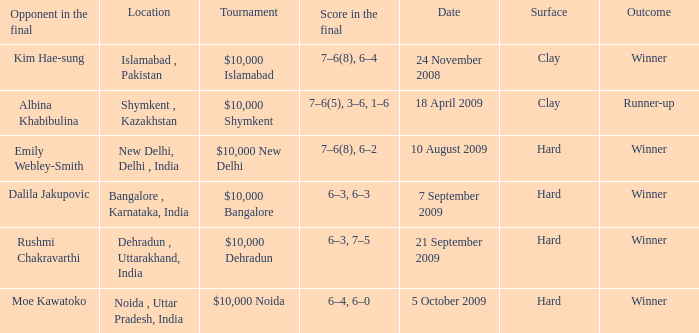What is the name of the tournament where outcome is runner-up $10,000 Shymkent. I'm looking to parse the entire table for insights. Could you assist me with that? {'header': ['Opponent in the final', 'Location', 'Tournament', 'Score in the final', 'Date', 'Surface', 'Outcome'], 'rows': [['Kim Hae-sung', 'Islamabad , Pakistan', '$10,000 Islamabad', '7–6(8), 6–4', '24 November 2008', 'Clay', 'Winner'], ['Albina Khabibulina', 'Shymkent , Kazakhstan', '$10,000 Shymkent', '7–6(5), 3–6, 1–6', '18 April 2009', 'Clay', 'Runner-up'], ['Emily Webley-Smith', 'New Delhi, Delhi , India', '$10,000 New Delhi', '7–6(8), 6–2', '10 August 2009', 'Hard', 'Winner'], ['Dalila Jakupovic', 'Bangalore , Karnataka, India', '$10,000 Bangalore', '6–3, 6–3', '7 September 2009', 'Hard', 'Winner'], ['Rushmi Chakravarthi', 'Dehradun , Uttarakhand, India', '$10,000 Dehradun', '6–3, 7–5', '21 September 2009', 'Hard', 'Winner'], ['Moe Kawatoko', 'Noida , Uttar Pradesh, India', '$10,000 Noida', '6–4, 6–0', '5 October 2009', 'Hard', 'Winner']]} 